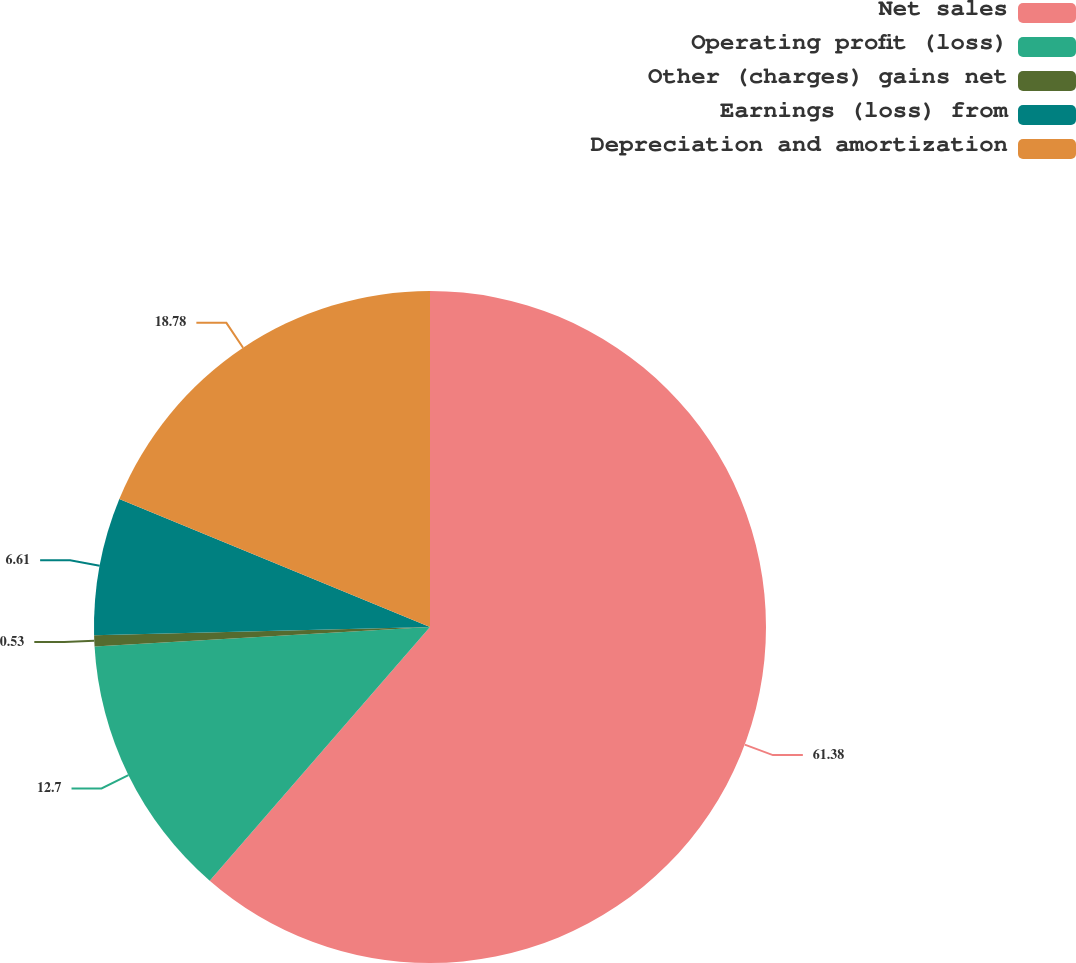Convert chart. <chart><loc_0><loc_0><loc_500><loc_500><pie_chart><fcel>Net sales<fcel>Operating profit (loss)<fcel>Other (charges) gains net<fcel>Earnings (loss) from<fcel>Depreciation and amortization<nl><fcel>61.38%<fcel>12.7%<fcel>0.53%<fcel>6.61%<fcel>18.78%<nl></chart> 